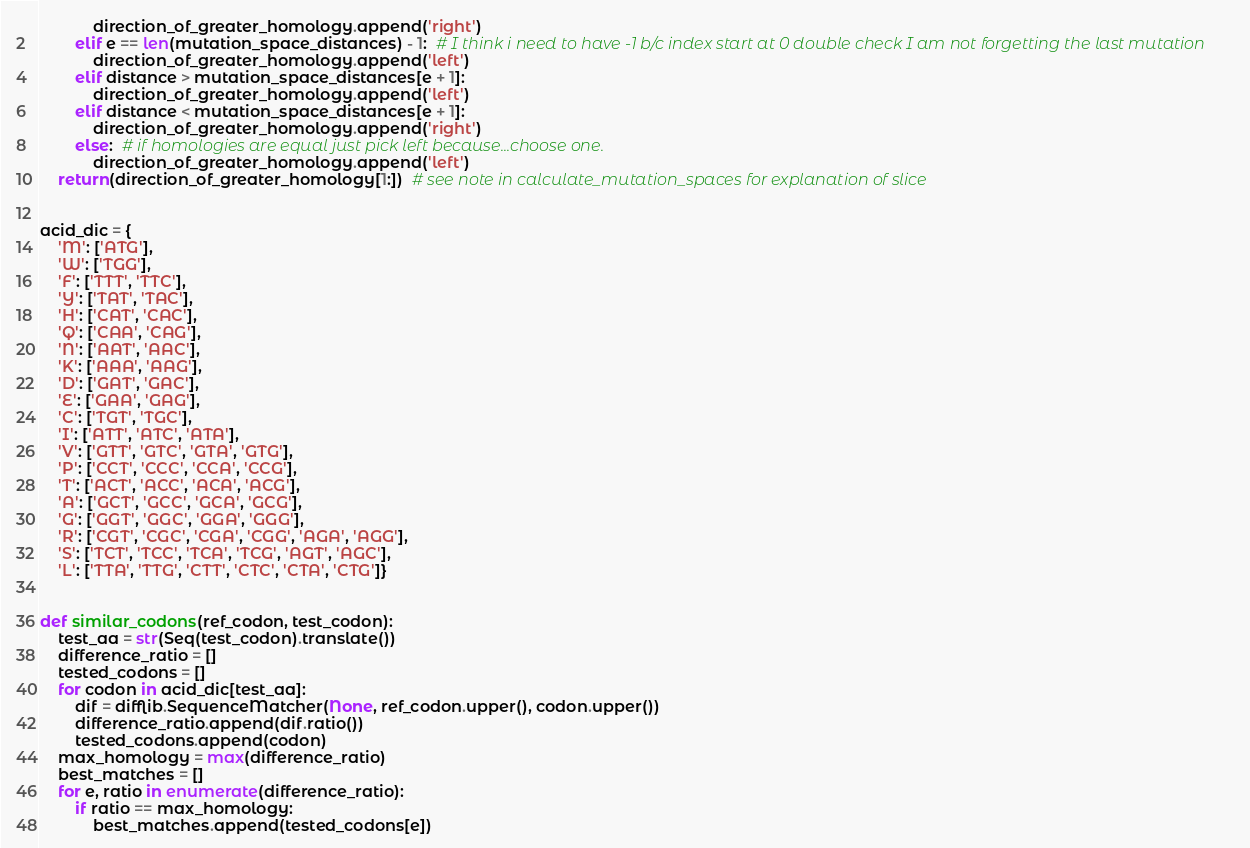Convert code to text. <code><loc_0><loc_0><loc_500><loc_500><_Python_>            direction_of_greater_homology.append('right')
        elif e == len(mutation_space_distances) - 1:  # I think i need to have -1 b/c index start at 0 double check I am not forgetting the last mutation
            direction_of_greater_homology.append('left')
        elif distance > mutation_space_distances[e + 1]:
            direction_of_greater_homology.append('left')
        elif distance < mutation_space_distances[e + 1]:
            direction_of_greater_homology.append('right')
        else:  # if homologies are equal just pick left because...choose one.
            direction_of_greater_homology.append('left')
    return(direction_of_greater_homology[1:])  # see note in calculate_mutation_spaces for explanation of slice


acid_dic = {
    'M': ['ATG'],
    'W': ['TGG'],
    'F': ['TTT', 'TTC'],
    'Y': ['TAT', 'TAC'],
    'H': ['CAT', 'CAC'],
    'Q': ['CAA', 'CAG'],
    'N': ['AAT', 'AAC'],
    'K': ['AAA', 'AAG'],
    'D': ['GAT', 'GAC'],
    'E': ['GAA', 'GAG'],
    'C': ['TGT', 'TGC'],
    'I': ['ATT', 'ATC', 'ATA'],
    'V': ['GTT', 'GTC', 'GTA', 'GTG'],
    'P': ['CCT', 'CCC', 'CCA', 'CCG'],
    'T': ['ACT', 'ACC', 'ACA', 'ACG'],
    'A': ['GCT', 'GCC', 'GCA', 'GCG'],
    'G': ['GGT', 'GGC', 'GGA', 'GGG'],
    'R': ['CGT', 'CGC', 'CGA', 'CGG', 'AGA', 'AGG'],
    'S': ['TCT', 'TCC', 'TCA', 'TCG', 'AGT', 'AGC'],
    'L': ['TTA', 'TTG', 'CTT', 'CTC', 'CTA', 'CTG']}


def similar_codons(ref_codon, test_codon):
    test_aa = str(Seq(test_codon).translate())
    difference_ratio = []
    tested_codons = []
    for codon in acid_dic[test_aa]:
        dif = difflib.SequenceMatcher(None, ref_codon.upper(), codon.upper())
        difference_ratio.append(dif.ratio())
        tested_codons.append(codon)
    max_homology = max(difference_ratio)
    best_matches = []
    for e, ratio in enumerate(difference_ratio):
        if ratio == max_homology:
            best_matches.append(tested_codons[e])</code> 